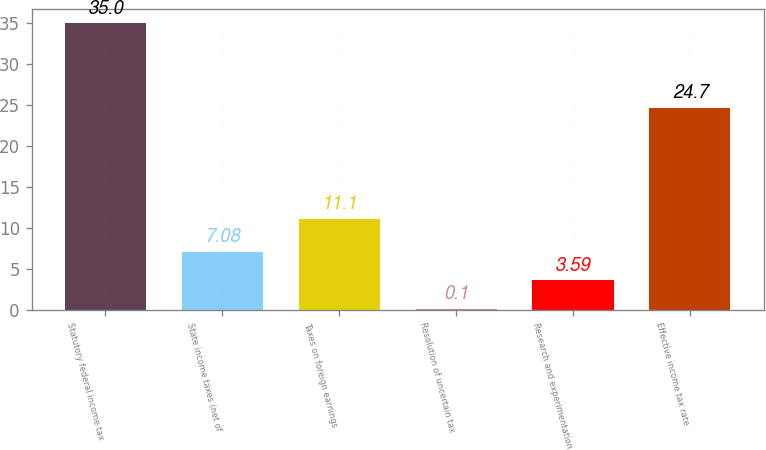Convert chart. <chart><loc_0><loc_0><loc_500><loc_500><bar_chart><fcel>Statutory federal income tax<fcel>State income taxes (net of<fcel>Taxes on foreign earnings<fcel>Resolution of uncertain tax<fcel>Research and experimentation<fcel>Effective income tax rate<nl><fcel>35<fcel>7.08<fcel>11.1<fcel>0.1<fcel>3.59<fcel>24.7<nl></chart> 